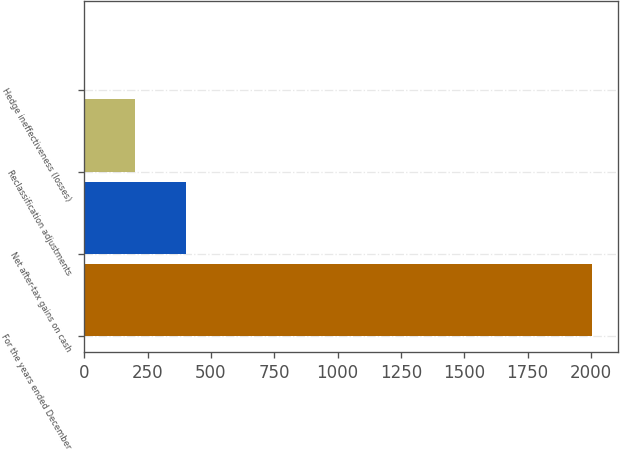<chart> <loc_0><loc_0><loc_500><loc_500><bar_chart><fcel>For the years ended December<fcel>Net after-tax gains on cash<fcel>Reclassification adjustments<fcel>Hedge ineffectiveness (losses)<nl><fcel>2006<fcel>402.8<fcel>202.4<fcel>2<nl></chart> 